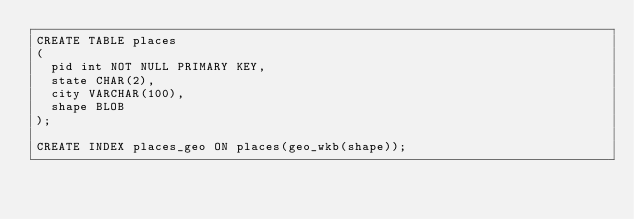Convert code to text. <code><loc_0><loc_0><loc_500><loc_500><_SQL_>CREATE TABLE places
(
  pid int NOT NULL PRIMARY KEY, 
  state CHAR(2),
  city VARCHAR(100),
  shape BLOB
);

CREATE INDEX places_geo ON places(geo_wkb(shape));
</code> 